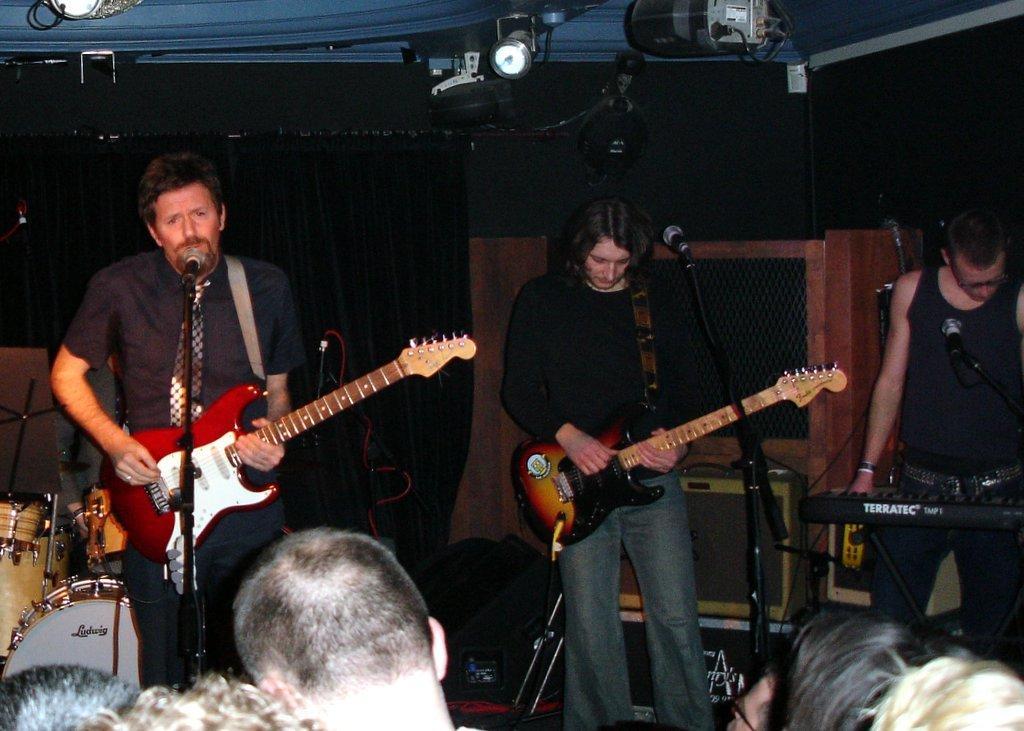Could you give a brief overview of what you see in this image? It is a music concert there are total three people on the Dias the first person is playing a guitar he is also singing the song to the right side second person is just playing the guitar and third person is playing the piano on the Dias there also few other instruments like drums and band,behind that black color curtain to the roof there are many lights in front of the there are some people they are enjoying the music. 